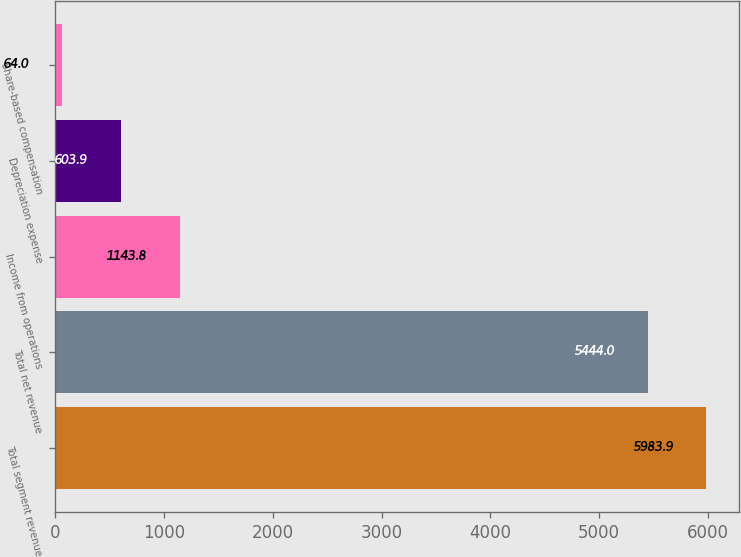Convert chart. <chart><loc_0><loc_0><loc_500><loc_500><bar_chart><fcel>Total segment revenue<fcel>Total net revenue<fcel>Income from operations<fcel>Depreciation expense<fcel>Share-based compensation<nl><fcel>5983.9<fcel>5444<fcel>1143.8<fcel>603.9<fcel>64<nl></chart> 